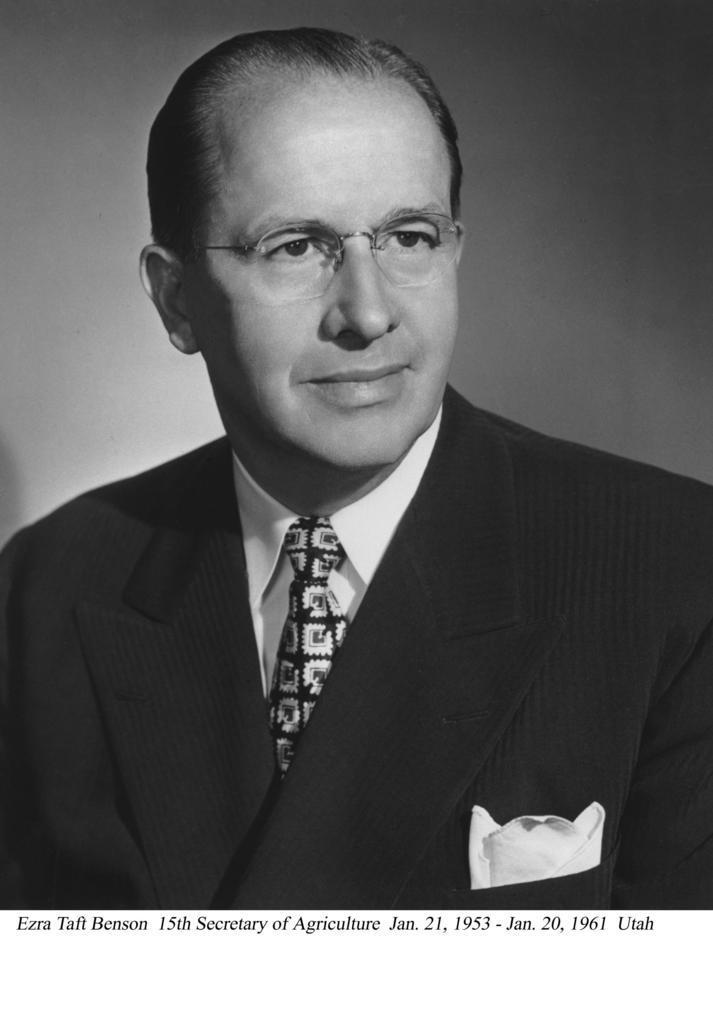Can you describe this image briefly? In the picture I can see a man who is wearing a coat, a shirt and a tie. I can also see something written on the image. The picture is black and white in color. 